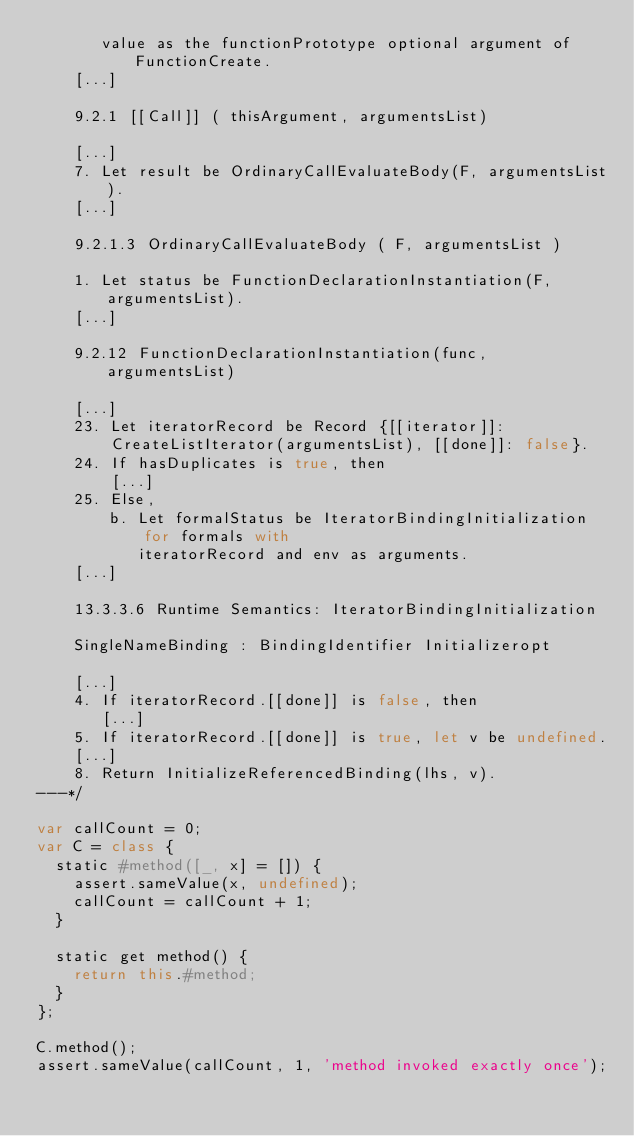Convert code to text. <code><loc_0><loc_0><loc_500><loc_500><_JavaScript_>       value as the functionPrototype optional argument of FunctionCreate.
    [...]

    9.2.1 [[Call]] ( thisArgument, argumentsList)

    [...]
    7. Let result be OrdinaryCallEvaluateBody(F, argumentsList).
    [...]

    9.2.1.3 OrdinaryCallEvaluateBody ( F, argumentsList )

    1. Let status be FunctionDeclarationInstantiation(F, argumentsList).
    [...]

    9.2.12 FunctionDeclarationInstantiation(func, argumentsList)

    [...]
    23. Let iteratorRecord be Record {[[iterator]]:
        CreateListIterator(argumentsList), [[done]]: false}.
    24. If hasDuplicates is true, then
        [...]
    25. Else,
        b. Let formalStatus be IteratorBindingInitialization for formals with
           iteratorRecord and env as arguments.
    [...]

    13.3.3.6 Runtime Semantics: IteratorBindingInitialization

    SingleNameBinding : BindingIdentifier Initializeropt

    [...]
    4. If iteratorRecord.[[done]] is false, then
       [...]
    5. If iteratorRecord.[[done]] is true, let v be undefined.
    [...]
    8. Return InitializeReferencedBinding(lhs, v).
---*/

var callCount = 0;
var C = class {
  static #method([_, x] = []) {
    assert.sameValue(x, undefined);
    callCount = callCount + 1;
  }

  static get method() {
    return this.#method;
  }
};

C.method();
assert.sameValue(callCount, 1, 'method invoked exactly once');
</code> 